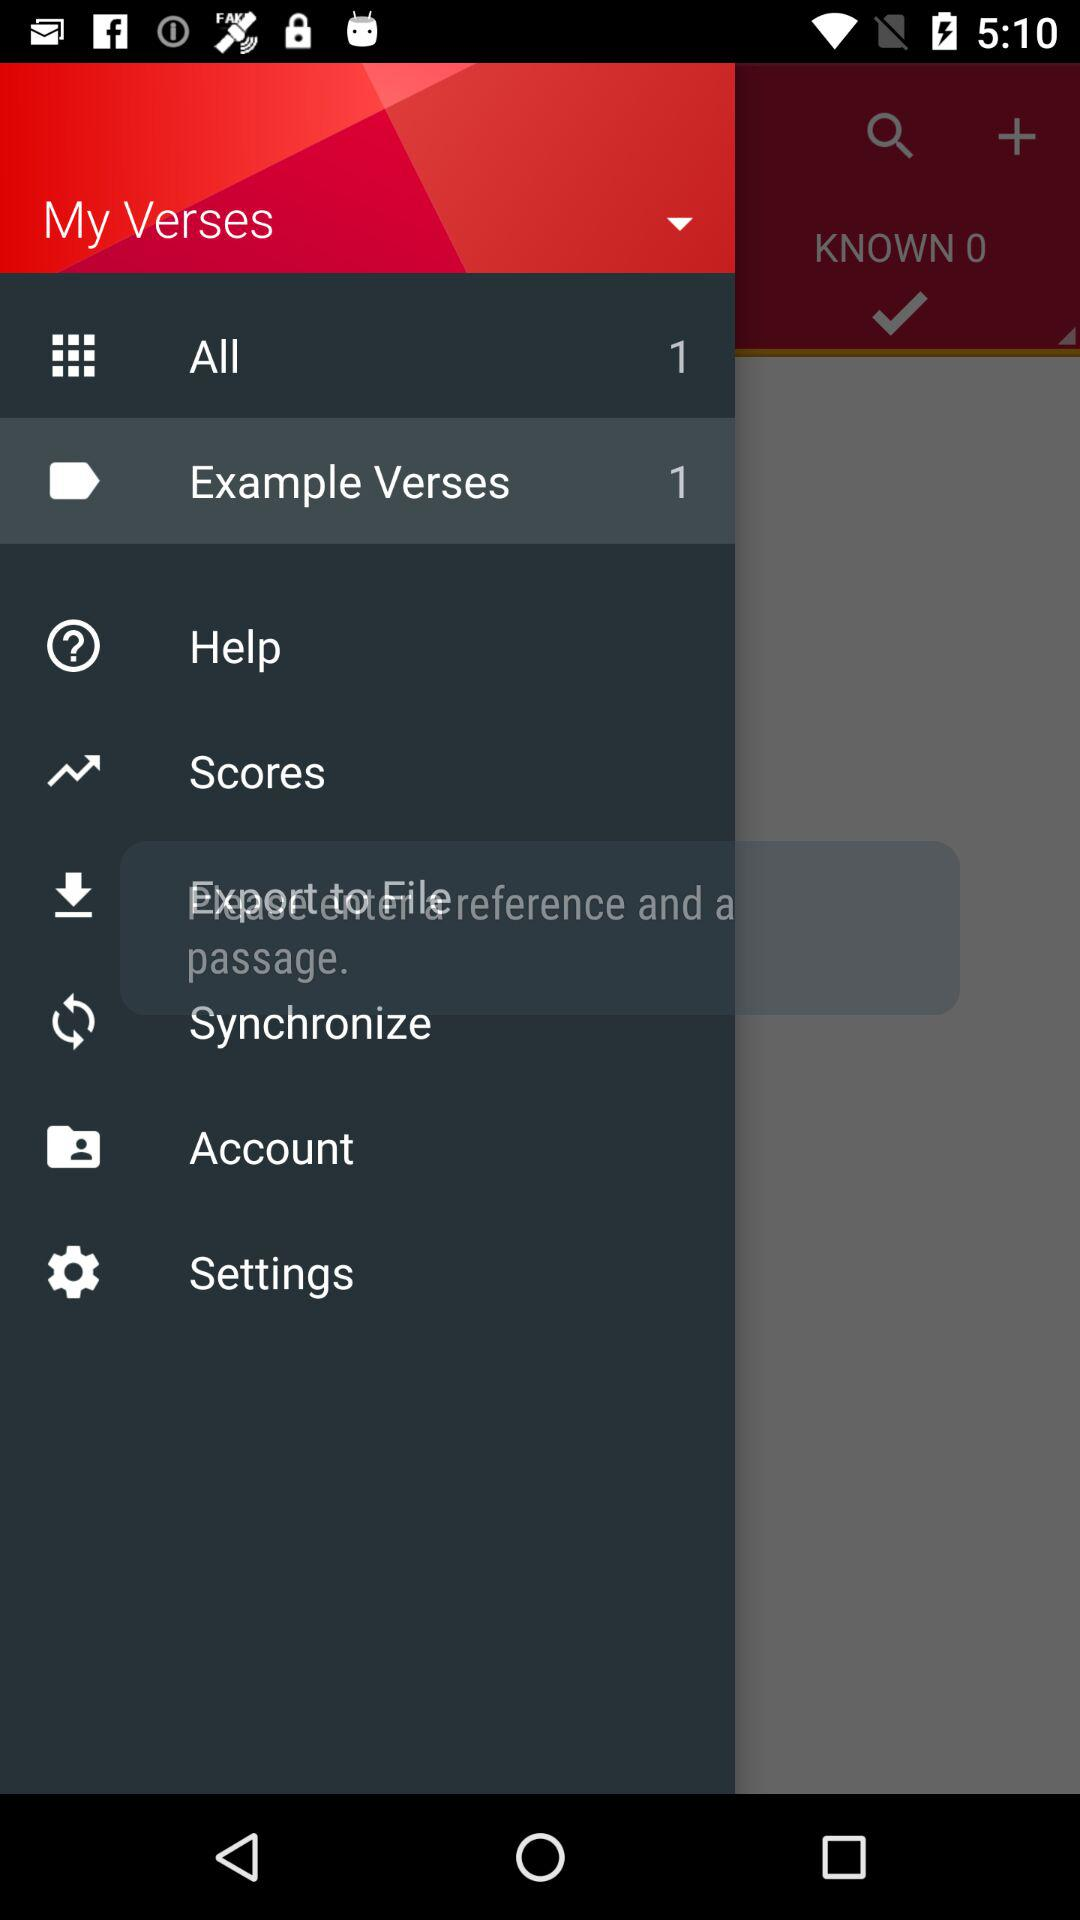How many example verses are there? There is only 1 example verses. 